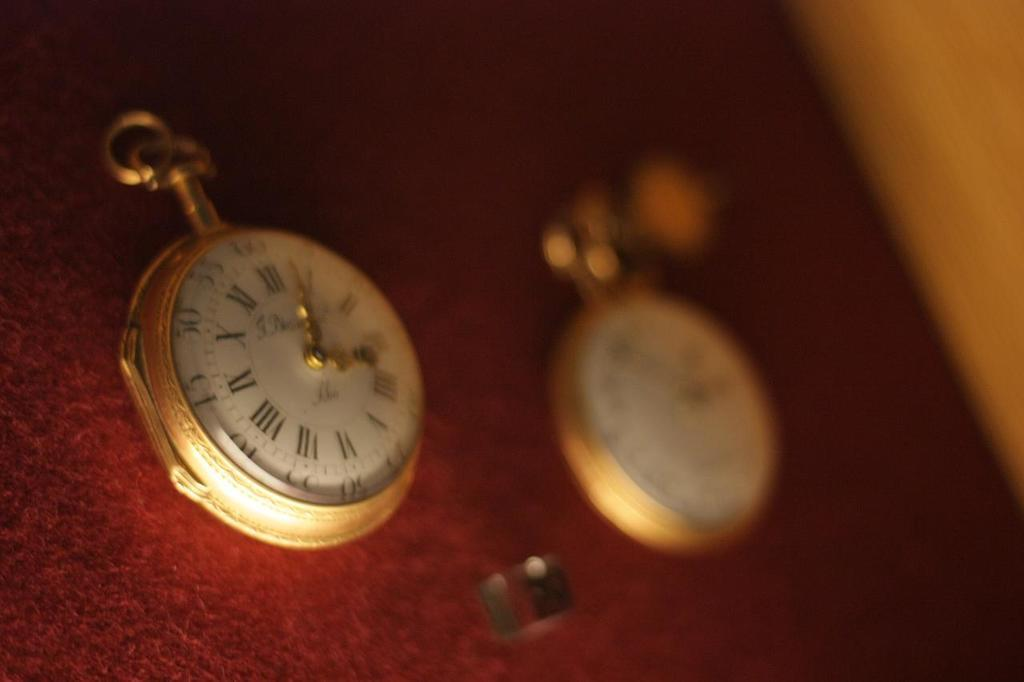<image>
Relay a brief, clear account of the picture shown. A pocket watch has the numeral XII at the top. 